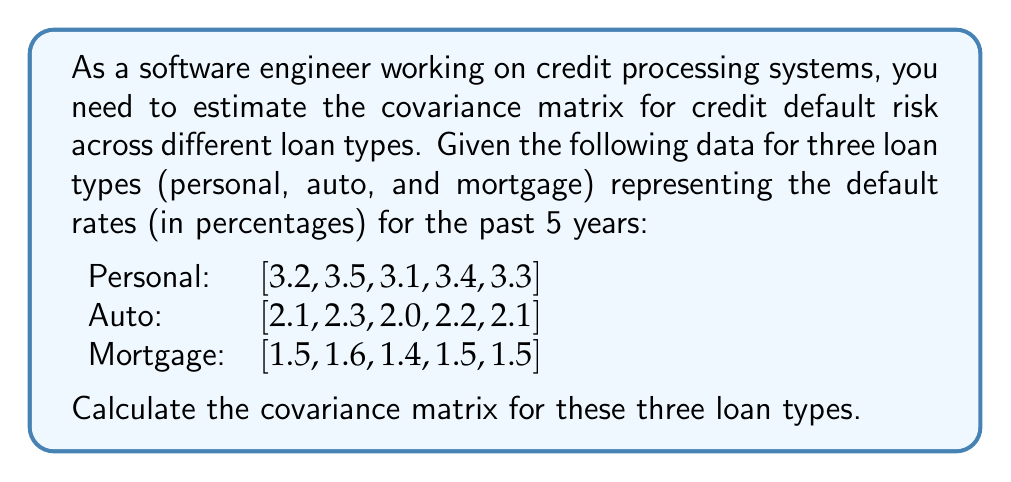Show me your answer to this math problem. To calculate the covariance matrix, we need to follow these steps:

1. Calculate the mean for each loan type:
   $$\bar{x}_{\text{personal}} = \frac{3.2 + 3.5 + 3.1 + 3.4 + 3.3}{5} = 3.3$$
   $$\bar{x}_{\text{auto}} = \frac{2.1 + 2.3 + 2.0 + 2.2 + 2.1}{5} = 2.14$$
   $$\bar{x}_{\text{mortgage}} = \frac{1.5 + 1.6 + 1.4 + 1.5 + 1.5}{5} = 1.5$$

2. Calculate the deviations from the mean for each loan type:
   Personal: [-0.1, 0.2, -0.2, 0.1, 0]
   Auto: [-0.04, 0.16, -0.14, 0.06, -0.04]
   Mortgage: [0, 0.1, -0.1, 0, 0]

3. Calculate the covariances:
   $$\text{Cov}(X,Y) = \frac{\sum_{i=1}^{n} (x_i - \bar{x})(y_i - \bar{y})}{n-1}$$

   a) Variance of Personal loans:
      $$\text{Cov(Personal, Personal)} = \frac{(-0.1)^2 + 0.2^2 + (-0.2)^2 + 0.1^2 + 0^2}{4} = 0.025$$

   b) Variance of Auto loans:
      $$\text{Cov(Auto, Auto)} = \frac{(-0.04)^2 + 0.16^2 + (-0.14)^2 + 0.06^2 + (-0.04)^2}{4} = 0.0112$$

   c) Variance of Mortgage loans:
      $$\text{Cov(Mortgage, Mortgage)} = \frac{0^2 + 0.1^2 + (-0.1)^2 + 0^2 + 0^2}{4} = 0.005$$

   d) Covariance between Personal and Auto loans:
      $$\text{Cov(Personal, Auto)} = \frac{(-0.1)(-0.04) + 0.2(0.16) + (-0.2)(-0.14) + 0.1(0.06) + 0(-0.04)}{4} = 0.0102$$

   e) Covariance between Personal and Mortgage loans:
      $$\text{Cov(Personal, Mortgage)} = \frac{(-0.1)(0) + 0.2(0.1) + (-0.2)(-0.1) + 0.1(0) + 0(0)}{4} = 0.0075$$

   f) Covariance between Auto and Mortgage loans:
      $$\text{Cov(Auto, Mortgage)} = \frac{(-0.04)(0) + 0.16(0.1) + (-0.14)(-0.1) + 0.06(0) + (-0.04)(0)}{4} = 0.0055$$

4. Construct the covariance matrix:
   $$\Sigma = \begin{bmatrix}
   \text{Cov(Personal, Personal)} & \text{Cov(Personal, Auto)} & \text{Cov(Personal, Mortgage)} \\
   \text{Cov(Auto, Personal)} & \text{Cov(Auto, Auto)} & \text{Cov(Auto, Mortgage)} \\
   \text{Cov(Mortgage, Personal)} & \text{Cov(Mortgage, Auto)} & \text{Cov(Mortgage, Mortgage)}
   \end{bmatrix}$$

   $$\Sigma = \begin{bmatrix}
   0.025 & 0.0102 & 0.0075 \\
   0.0102 & 0.0112 & 0.0055 \\
   0.0075 & 0.0055 & 0.005
   \end{bmatrix}$$
Answer: The estimated covariance matrix for credit default risk across different loan types is:

$$\Sigma = \begin{bmatrix}
0.025 & 0.0102 & 0.0075 \\
0.0102 & 0.0112 & 0.0055 \\
0.0075 & 0.0055 & 0.005
\end{bmatrix}$$ 